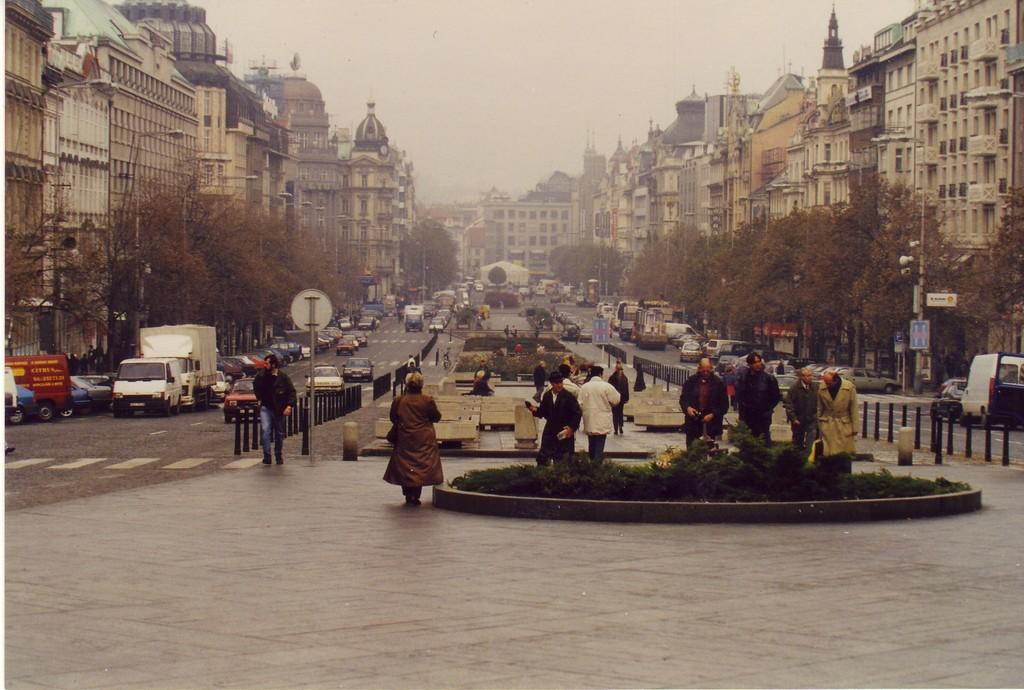What is the main feature in the image? There is a fountain in the image. Are there any people present in the image? Yes, there are people in the image. What else can be seen on the road in the image? There are vehicles on the road in the image. Can you describe the background of the image? In the background of the image, there are poles, name boards, sign boards, trees, and buildings. Where is the shelf located in the image? There is no shelf present in the image. What type of bucket can be seen in the image? There is no bucket present in the image. 